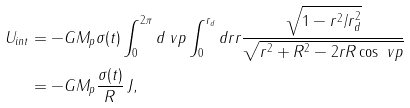<formula> <loc_0><loc_0><loc_500><loc_500>U _ { i n t } & = - G M _ { p } \sigma ( t ) \int _ { 0 } ^ { 2 \pi } d \ v p \int _ { 0 } ^ { r _ { d } } d r r \frac { \sqrt { 1 - r ^ { 2 } / r _ { d } ^ { 2 } } } { \sqrt { r ^ { 2 } + R ^ { 2 } - 2 r R \cos \ v p } } \\ & = - G M _ { p } \frac { \sigma ( t ) } { R } \, J ,</formula> 